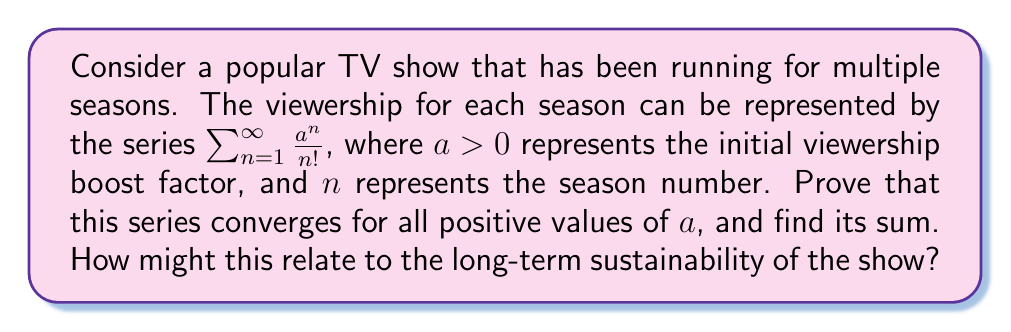Show me your answer to this math problem. To prove the convergence of this series and find its sum, we'll follow these steps:

1) First, let's recognize that this series resembles the Taylor series expansion of $e^x$:

   $$e^x = 1 + x + \frac{x^2}{2!} + \frac{x^3}{3!} + \cdots = \sum_{n=0}^{\infty} \frac{x^n}{n!}$$

2) Our series starts from $n=1$ instead of $n=0$, so we can rewrite it as:

   $$\sum_{n=1}^{\infty} \frac{a^n}{n!} = \left(\sum_{n=0}^{\infty} \frac{a^n}{n!}\right) - 1 = e^a - 1$$

3) To prove convergence, we can use the ratio test:

   $$\lim_{n \to \infty} \left|\frac{a_{n+1}}{a_n}\right| = \lim_{n \to \infty} \left|\frac{a^{n+1}/(n+1)!}{a^n/n!}\right| = \lim_{n \to \infty} \left|\frac{a}{n+1}\right| = 0$$

   Since this limit is less than 1, the series converges for all positive values of $a$.

4) Therefore, the sum of the series is $e^a - 1$ for all $a > 0$.

Relating this to TV show viewership:
- The factor $a$ represents the initial boost in viewership, which could be due to marketing, word-of-mouth, or critical acclaim.
- The factorial term in the denominator suggests that the impact of this initial boost diminishes rapidly with each season.
- The convergence of the series implies that even with a large initial boost, the cumulative additional viewership has a limit.
- The exponential nature of the sum ($e^a - 1$) indicates that small changes in the initial boost can have significant effects on long-term viewership.

This model suggests that while a strong start is important, it's not sufficient for long-term sustainability. The show would need to continually reinvent itself or find new ways to attract viewers to maintain or grow its audience beyond what the initial boost provides.
Answer: The series $\sum_{n=1}^{\infty} \frac{a^n}{n!}$ converges for all positive values of $a$, and its sum is $e^a - 1$. 